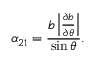Convert formula to latex. <formula><loc_0><loc_0><loc_500><loc_500>\alpha _ { 2 1 } = \frac { b \left | \frac { \partial b } { \partial \theta } \right | } { \sin \theta } .</formula> 